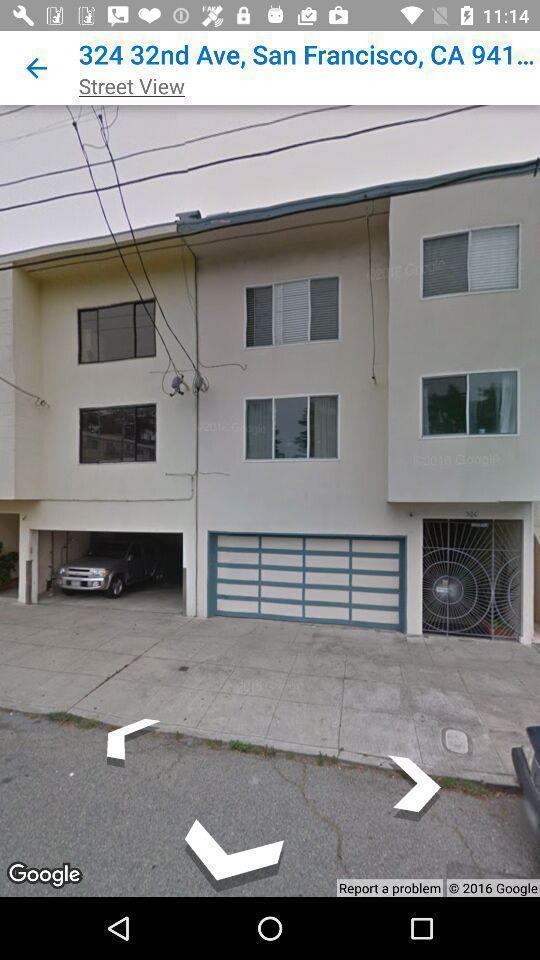What details can you identify in this image? Screen the showing the street view of the location. 